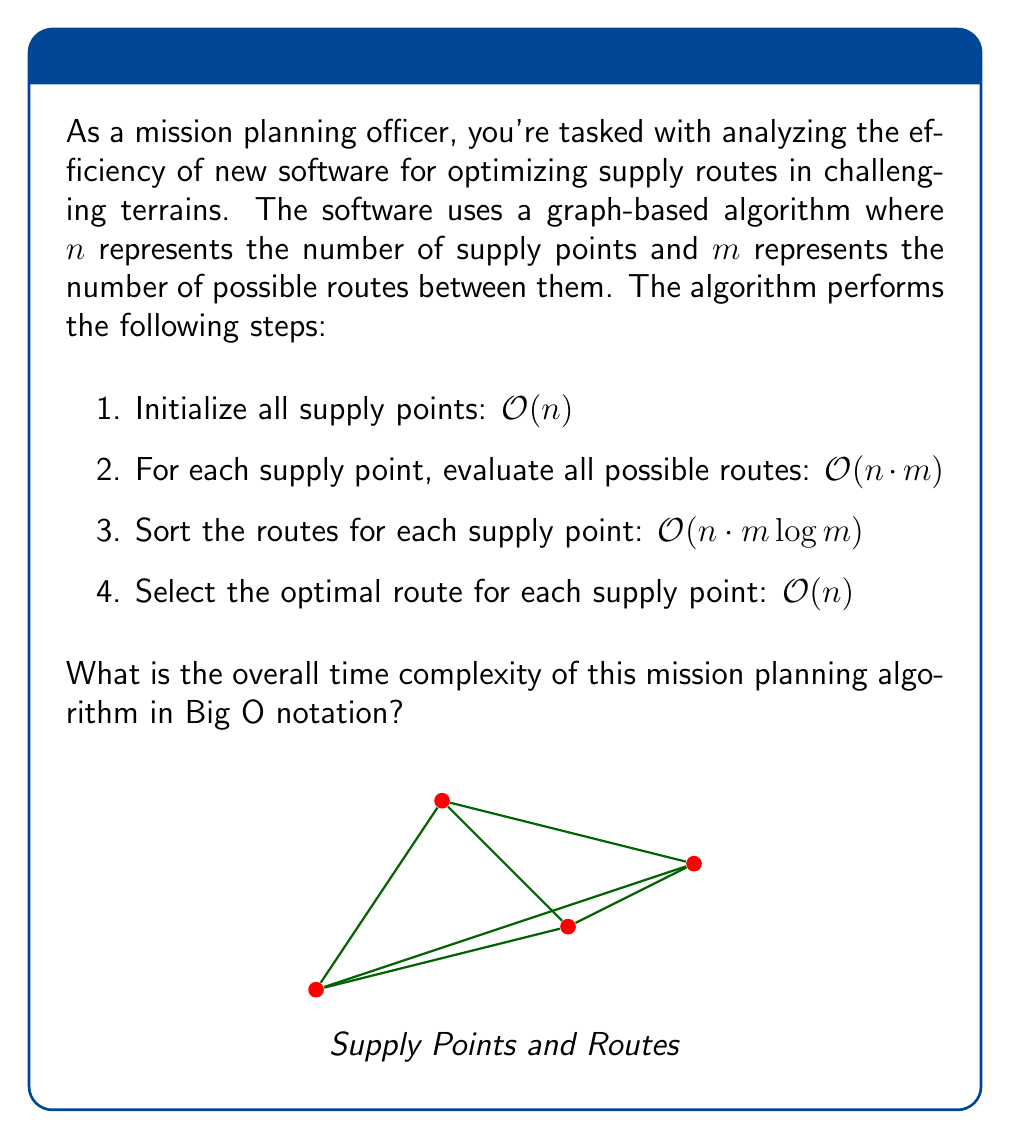Can you answer this question? To determine the overall time complexity, we need to analyze each step of the algorithm and identify the dominant term:

1. Initializing all supply points: $O(n)$
   This step has a linear time complexity in terms of the number of supply points.

2. Evaluating all possible routes for each supply point: $O(n \cdot m)$
   For each of the $n$ supply points, we evaluate $m$ routes, resulting in a complexity of $O(n \cdot m)$.

3. Sorting the routes for each supply point: $O(n \cdot m \log m)$
   For each of the $n$ supply points, we sort $m$ routes. Assuming an efficient sorting algorithm like quicksort or mergesort is used, the complexity of sorting is $O(m \log m)$. Since this is done for each of the $n$ points, the overall complexity of this step is $O(n \cdot m \log m)$.

4. Selecting the optimal route for each supply point: $O(n)$
   This step has a linear time complexity in terms of the number of supply points.

To determine the overall time complexity, we need to sum up these individual complexities:

$$O(n) + O(n \cdot m) + O(n \cdot m \log m) + O(n)$$

The dominant term in this sum is $O(n \cdot m \log m)$, as it grows faster than the others for large values of $n$ and $m$. Therefore, we can simplify the overall time complexity to:

$$O(n \cdot m \log m)$$

This represents the worst-case time complexity of the mission planning algorithm.
Answer: $O(n \cdot m \log m)$ 